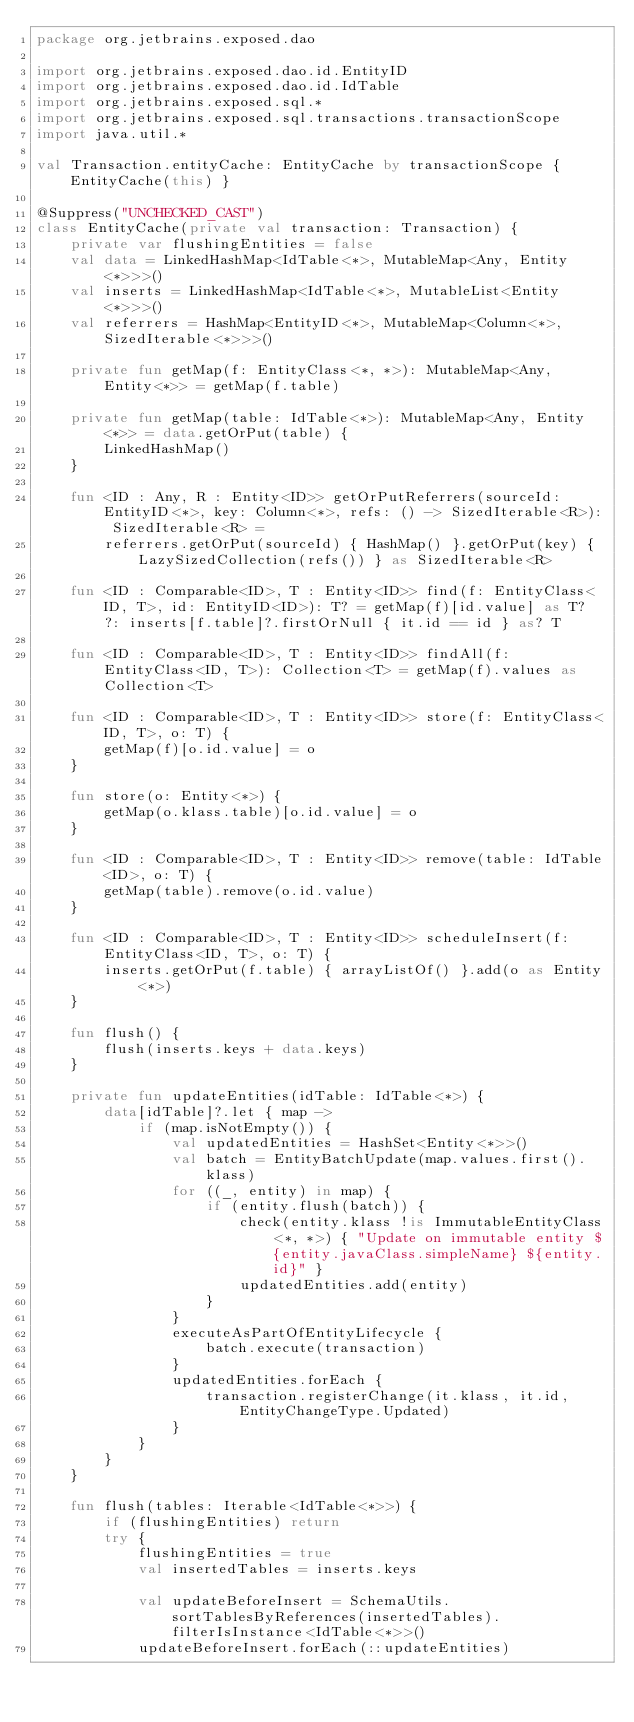<code> <loc_0><loc_0><loc_500><loc_500><_Kotlin_>package org.jetbrains.exposed.dao

import org.jetbrains.exposed.dao.id.EntityID
import org.jetbrains.exposed.dao.id.IdTable
import org.jetbrains.exposed.sql.*
import org.jetbrains.exposed.sql.transactions.transactionScope
import java.util.*

val Transaction.entityCache: EntityCache by transactionScope { EntityCache(this) }

@Suppress("UNCHECKED_CAST")
class EntityCache(private val transaction: Transaction) {
    private var flushingEntities = false
    val data = LinkedHashMap<IdTable<*>, MutableMap<Any, Entity<*>>>()
    val inserts = LinkedHashMap<IdTable<*>, MutableList<Entity<*>>>()
    val referrers = HashMap<EntityID<*>, MutableMap<Column<*>, SizedIterable<*>>>()

    private fun getMap(f: EntityClass<*, *>): MutableMap<Any, Entity<*>> = getMap(f.table)

    private fun getMap(table: IdTable<*>): MutableMap<Any, Entity<*>> = data.getOrPut(table) {
        LinkedHashMap()
    }

    fun <ID : Any, R : Entity<ID>> getOrPutReferrers(sourceId: EntityID<*>, key: Column<*>, refs: () -> SizedIterable<R>): SizedIterable<R> =
        referrers.getOrPut(sourceId) { HashMap() }.getOrPut(key) { LazySizedCollection(refs()) } as SizedIterable<R>

    fun <ID : Comparable<ID>, T : Entity<ID>> find(f: EntityClass<ID, T>, id: EntityID<ID>): T? = getMap(f)[id.value] as T? ?: inserts[f.table]?.firstOrNull { it.id == id } as? T

    fun <ID : Comparable<ID>, T : Entity<ID>> findAll(f: EntityClass<ID, T>): Collection<T> = getMap(f).values as Collection<T>

    fun <ID : Comparable<ID>, T : Entity<ID>> store(f: EntityClass<ID, T>, o: T) {
        getMap(f)[o.id.value] = o
    }

    fun store(o: Entity<*>) {
        getMap(o.klass.table)[o.id.value] = o
    }

    fun <ID : Comparable<ID>, T : Entity<ID>> remove(table: IdTable<ID>, o: T) {
        getMap(table).remove(o.id.value)
    }

    fun <ID : Comparable<ID>, T : Entity<ID>> scheduleInsert(f: EntityClass<ID, T>, o: T) {
        inserts.getOrPut(f.table) { arrayListOf() }.add(o as Entity<*>)
    }

    fun flush() {
        flush(inserts.keys + data.keys)
    }

    private fun updateEntities(idTable: IdTable<*>) {
        data[idTable]?.let { map ->
            if (map.isNotEmpty()) {
                val updatedEntities = HashSet<Entity<*>>()
                val batch = EntityBatchUpdate(map.values.first().klass)
                for ((_, entity) in map) {
                    if (entity.flush(batch)) {
                        check(entity.klass !is ImmutableEntityClass<*, *>) { "Update on immutable entity ${entity.javaClass.simpleName} ${entity.id}" }
                        updatedEntities.add(entity)
                    }
                }
                executeAsPartOfEntityLifecycle {
                    batch.execute(transaction)
                }
                updatedEntities.forEach {
                    transaction.registerChange(it.klass, it.id, EntityChangeType.Updated)
                }
            }
        }
    }

    fun flush(tables: Iterable<IdTable<*>>) {
        if (flushingEntities) return
        try {
            flushingEntities = true
            val insertedTables = inserts.keys

            val updateBeforeInsert = SchemaUtils.sortTablesByReferences(insertedTables).filterIsInstance<IdTable<*>>()
            updateBeforeInsert.forEach(::updateEntities)
</code> 